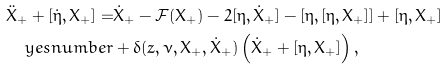Convert formula to latex. <formula><loc_0><loc_0><loc_500><loc_500>\ddot { X } _ { + } + [ \dot { \eta } , X _ { + } ] = & \dot { X } _ { + } - \mathcal { F } ( X _ { + } ) - 2 [ \eta , \dot { X } _ { + } ] - [ \eta , [ \eta , X _ { + } ] ] + [ \eta , X _ { + } ] \\ \ y e s n u m b e r & + \delta ( z , \nu , X _ { + } , \dot { X } _ { + } ) \left ( \dot { X } _ { + } + [ \eta , X _ { + } ] \right ) ,</formula> 